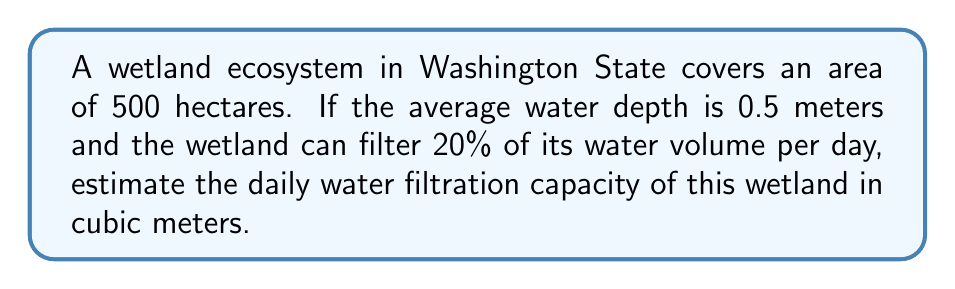Give your solution to this math problem. To solve this problem, we'll follow these steps:

1. Calculate the total volume of water in the wetland:
   Area = 500 hectares = 500 × 10,000 m² = 5,000,000 m²
   Depth = 0.5 m
   Volume = Area × Depth
   $$V = 5,000,000 \text{ m}^2 \times 0.5 \text{ m} = 2,500,000 \text{ m}^3$$

2. Calculate the daily filtration capacity:
   Filtration rate = 20% = 0.2
   Daily filtration capacity = Total volume × Filtration rate
   $$C = 2,500,000 \text{ m}^3 \times 0.2 = 500,000 \text{ m}^3$$

Therefore, the daily water filtration capacity of the wetland is 500,000 cubic meters.
Answer: 500,000 m³ 